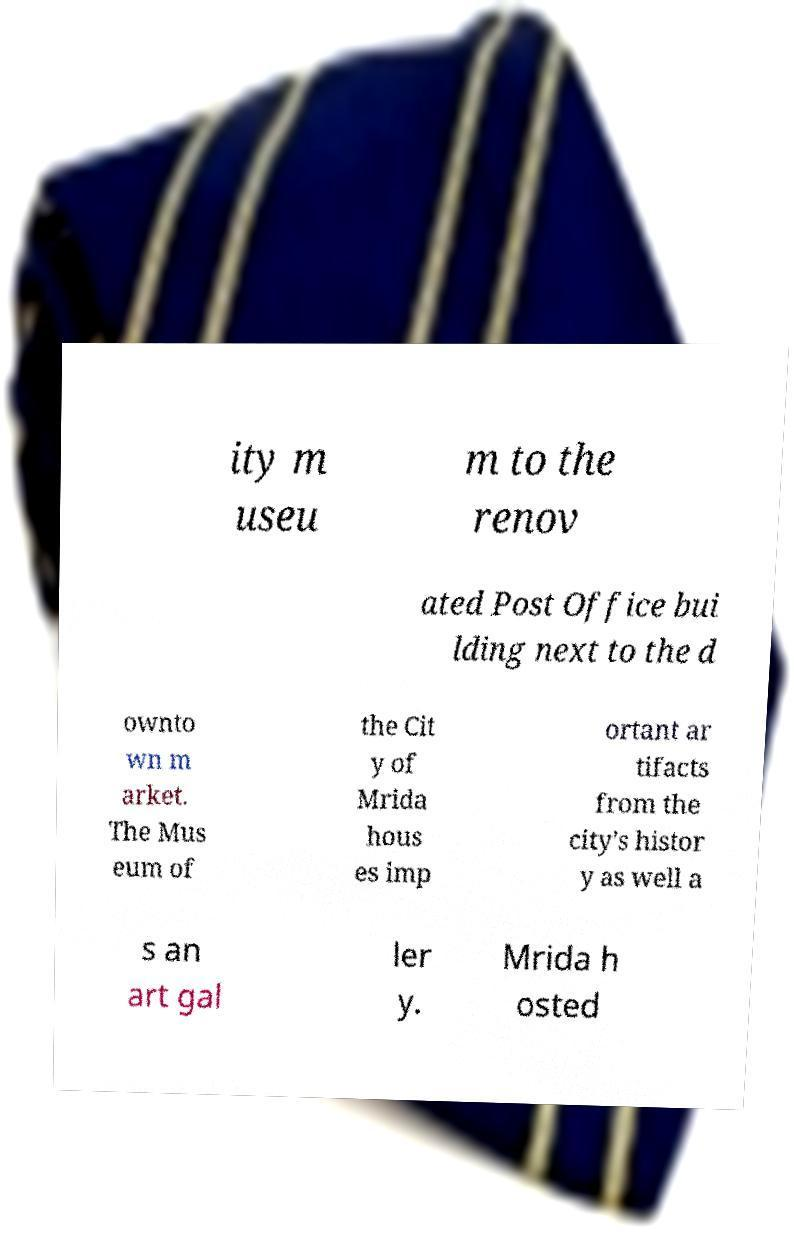Can you accurately transcribe the text from the provided image for me? ity m useu m to the renov ated Post Office bui lding next to the d ownto wn m arket. The Mus eum of the Cit y of Mrida hous es imp ortant ar tifacts from the city's histor y as well a s an art gal ler y. Mrida h osted 